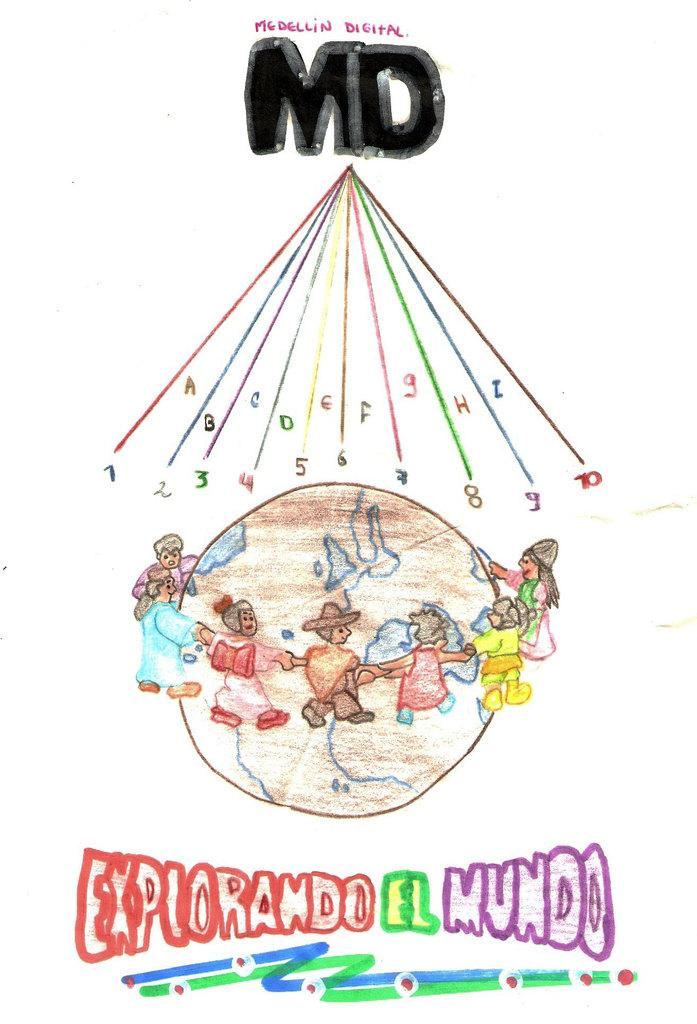<image>
Offer a succinct explanation of the picture presented. picture of explorando el mundo drawing its colorful 